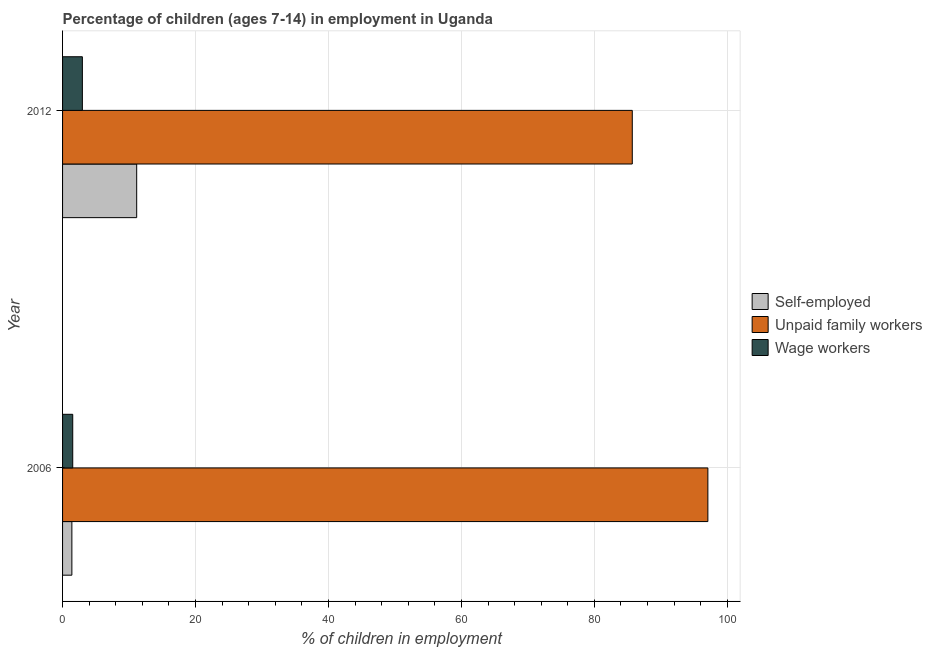How many different coloured bars are there?
Make the answer very short. 3. How many groups of bars are there?
Offer a very short reply. 2. Are the number of bars on each tick of the Y-axis equal?
Offer a terse response. Yes. How many bars are there on the 1st tick from the top?
Provide a short and direct response. 3. What is the label of the 2nd group of bars from the top?
Your answer should be very brief. 2006. Across all years, what is the maximum percentage of self employed children?
Provide a short and direct response. 11.15. Across all years, what is the minimum percentage of self employed children?
Provide a short and direct response. 1.4. What is the total percentage of children employed as wage workers in the graph?
Your response must be concise. 4.51. What is the difference between the percentage of children employed as wage workers in 2006 and that in 2012?
Your answer should be very brief. -1.45. What is the difference between the percentage of children employed as unpaid family workers in 2006 and the percentage of children employed as wage workers in 2012?
Your answer should be very brief. 94.09. What is the average percentage of self employed children per year?
Offer a terse response. 6.28. In the year 2006, what is the difference between the percentage of children employed as unpaid family workers and percentage of self employed children?
Offer a terse response. 95.67. In how many years, is the percentage of children employed as wage workers greater than 60 %?
Make the answer very short. 0. What is the ratio of the percentage of self employed children in 2006 to that in 2012?
Keep it short and to the point. 0.13. Is the percentage of children employed as wage workers in 2006 less than that in 2012?
Give a very brief answer. Yes. In how many years, is the percentage of self employed children greater than the average percentage of self employed children taken over all years?
Provide a succinct answer. 1. What does the 1st bar from the top in 2006 represents?
Make the answer very short. Wage workers. What does the 3rd bar from the bottom in 2006 represents?
Ensure brevity in your answer.  Wage workers. Is it the case that in every year, the sum of the percentage of self employed children and percentage of children employed as unpaid family workers is greater than the percentage of children employed as wage workers?
Keep it short and to the point. Yes. Are all the bars in the graph horizontal?
Provide a short and direct response. Yes. How many years are there in the graph?
Offer a terse response. 2. How are the legend labels stacked?
Offer a terse response. Vertical. What is the title of the graph?
Keep it short and to the point. Percentage of children (ages 7-14) in employment in Uganda. Does "Maunufacturing" appear as one of the legend labels in the graph?
Give a very brief answer. No. What is the label or title of the X-axis?
Give a very brief answer. % of children in employment. What is the label or title of the Y-axis?
Ensure brevity in your answer.  Year. What is the % of children in employment in Unpaid family workers in 2006?
Offer a very short reply. 97.07. What is the % of children in employment in Wage workers in 2006?
Give a very brief answer. 1.53. What is the % of children in employment of Self-employed in 2012?
Ensure brevity in your answer.  11.15. What is the % of children in employment in Unpaid family workers in 2012?
Your response must be concise. 85.7. What is the % of children in employment of Wage workers in 2012?
Make the answer very short. 2.98. Across all years, what is the maximum % of children in employment in Self-employed?
Offer a terse response. 11.15. Across all years, what is the maximum % of children in employment in Unpaid family workers?
Your answer should be very brief. 97.07. Across all years, what is the maximum % of children in employment of Wage workers?
Give a very brief answer. 2.98. Across all years, what is the minimum % of children in employment in Self-employed?
Keep it short and to the point. 1.4. Across all years, what is the minimum % of children in employment of Unpaid family workers?
Your response must be concise. 85.7. Across all years, what is the minimum % of children in employment in Wage workers?
Provide a short and direct response. 1.53. What is the total % of children in employment in Self-employed in the graph?
Ensure brevity in your answer.  12.55. What is the total % of children in employment in Unpaid family workers in the graph?
Provide a succinct answer. 182.77. What is the total % of children in employment of Wage workers in the graph?
Ensure brevity in your answer.  4.51. What is the difference between the % of children in employment in Self-employed in 2006 and that in 2012?
Your response must be concise. -9.75. What is the difference between the % of children in employment of Unpaid family workers in 2006 and that in 2012?
Offer a very short reply. 11.37. What is the difference between the % of children in employment in Wage workers in 2006 and that in 2012?
Offer a very short reply. -1.45. What is the difference between the % of children in employment of Self-employed in 2006 and the % of children in employment of Unpaid family workers in 2012?
Keep it short and to the point. -84.3. What is the difference between the % of children in employment of Self-employed in 2006 and the % of children in employment of Wage workers in 2012?
Your answer should be very brief. -1.58. What is the difference between the % of children in employment of Unpaid family workers in 2006 and the % of children in employment of Wage workers in 2012?
Your answer should be compact. 94.09. What is the average % of children in employment of Self-employed per year?
Your answer should be compact. 6.28. What is the average % of children in employment of Unpaid family workers per year?
Ensure brevity in your answer.  91.39. What is the average % of children in employment of Wage workers per year?
Give a very brief answer. 2.25. In the year 2006, what is the difference between the % of children in employment of Self-employed and % of children in employment of Unpaid family workers?
Provide a short and direct response. -95.67. In the year 2006, what is the difference between the % of children in employment of Self-employed and % of children in employment of Wage workers?
Make the answer very short. -0.13. In the year 2006, what is the difference between the % of children in employment of Unpaid family workers and % of children in employment of Wage workers?
Give a very brief answer. 95.54. In the year 2012, what is the difference between the % of children in employment of Self-employed and % of children in employment of Unpaid family workers?
Your response must be concise. -74.55. In the year 2012, what is the difference between the % of children in employment in Self-employed and % of children in employment in Wage workers?
Your answer should be compact. 8.17. In the year 2012, what is the difference between the % of children in employment of Unpaid family workers and % of children in employment of Wage workers?
Your answer should be very brief. 82.72. What is the ratio of the % of children in employment in Self-employed in 2006 to that in 2012?
Your answer should be very brief. 0.13. What is the ratio of the % of children in employment in Unpaid family workers in 2006 to that in 2012?
Give a very brief answer. 1.13. What is the ratio of the % of children in employment of Wage workers in 2006 to that in 2012?
Your response must be concise. 0.51. What is the difference between the highest and the second highest % of children in employment of Self-employed?
Give a very brief answer. 9.75. What is the difference between the highest and the second highest % of children in employment in Unpaid family workers?
Provide a succinct answer. 11.37. What is the difference between the highest and the second highest % of children in employment of Wage workers?
Your response must be concise. 1.45. What is the difference between the highest and the lowest % of children in employment in Self-employed?
Make the answer very short. 9.75. What is the difference between the highest and the lowest % of children in employment of Unpaid family workers?
Offer a terse response. 11.37. What is the difference between the highest and the lowest % of children in employment in Wage workers?
Provide a short and direct response. 1.45. 